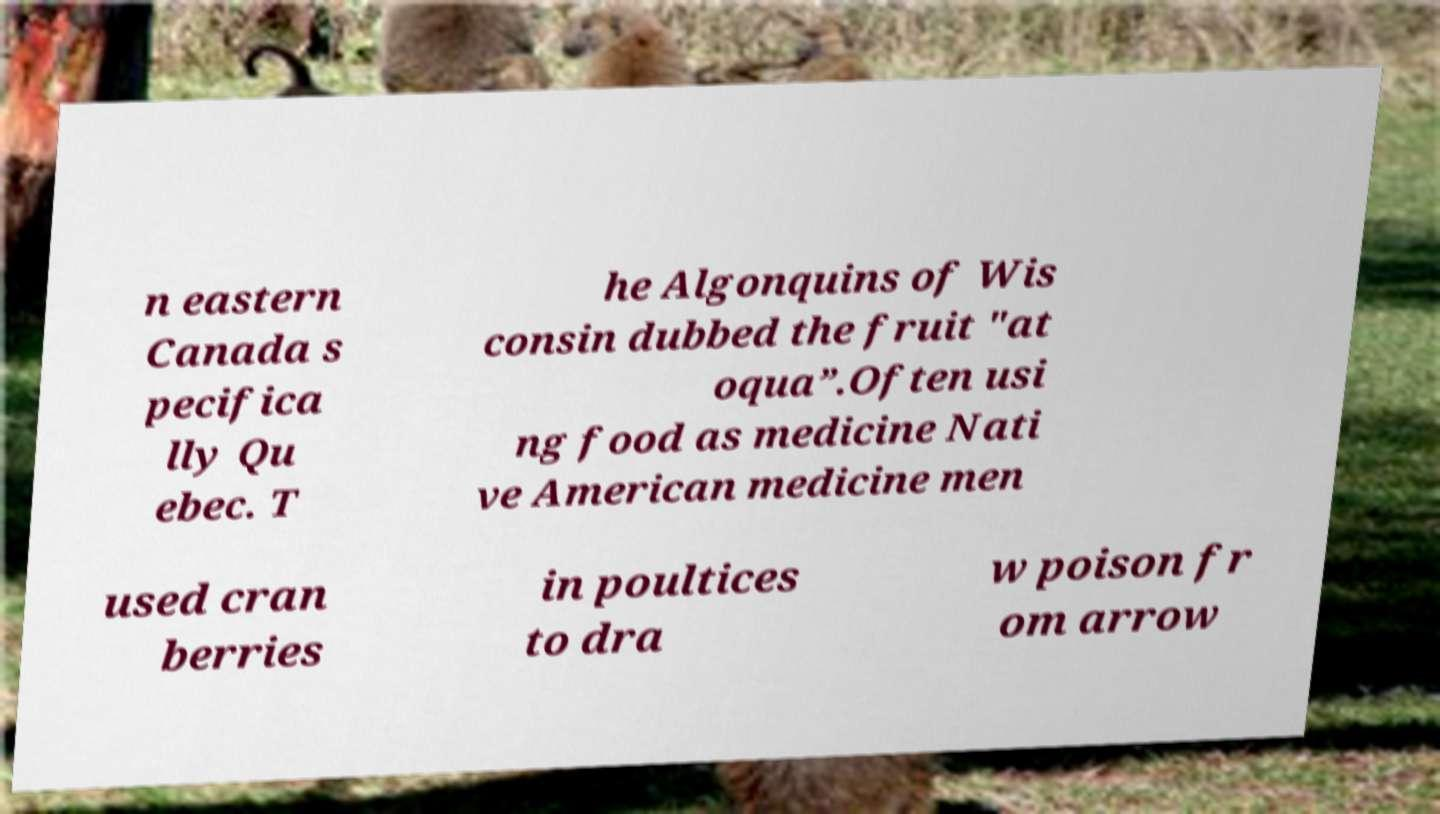For documentation purposes, I need the text within this image transcribed. Could you provide that? n eastern Canada s pecifica lly Qu ebec. T he Algonquins of Wis consin dubbed the fruit "at oqua”.Often usi ng food as medicine Nati ve American medicine men used cran berries in poultices to dra w poison fr om arrow 